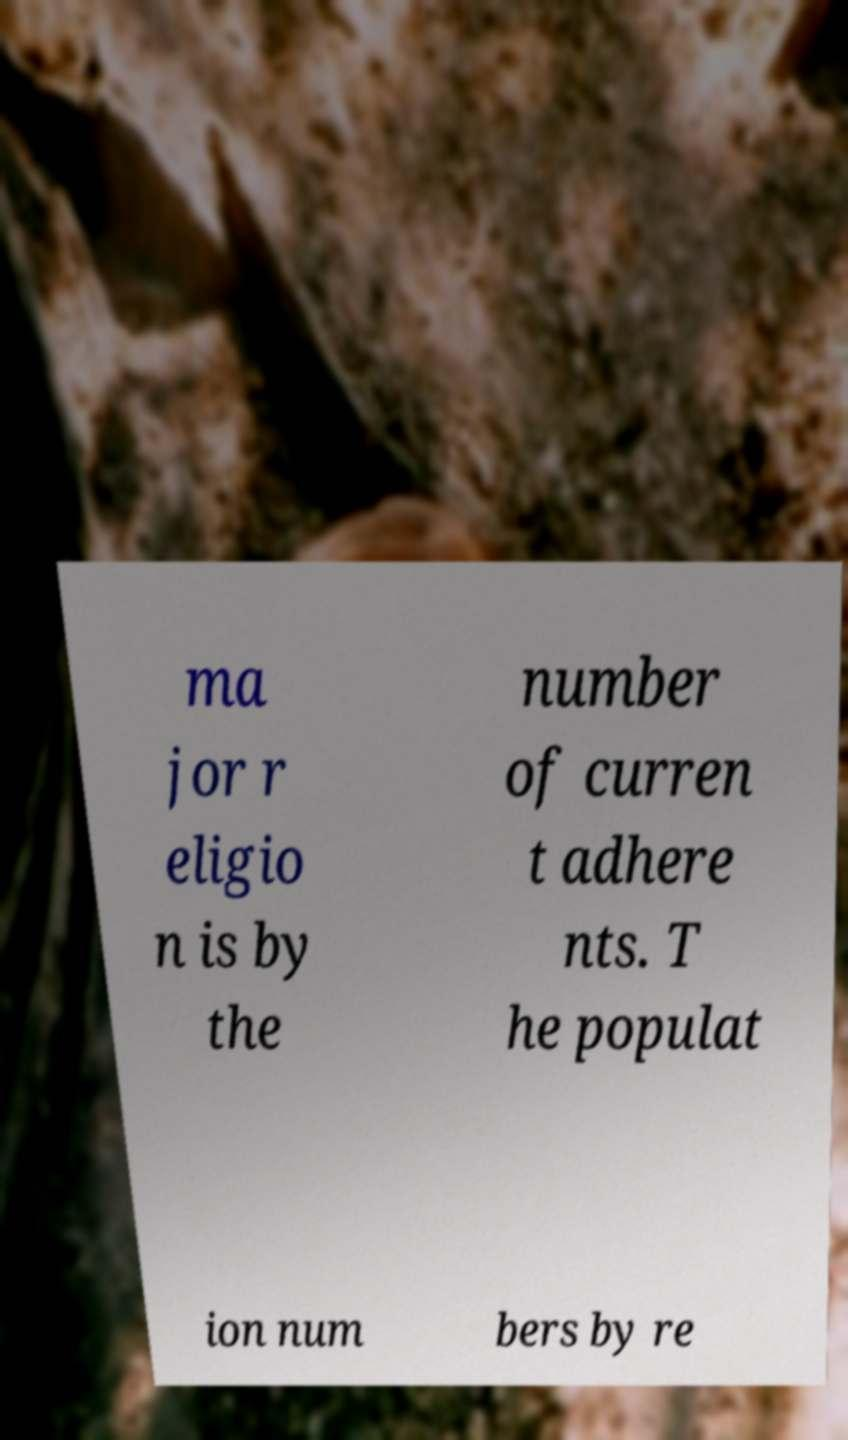Please read and relay the text visible in this image. What does it say? ma jor r eligio n is by the number of curren t adhere nts. T he populat ion num bers by re 